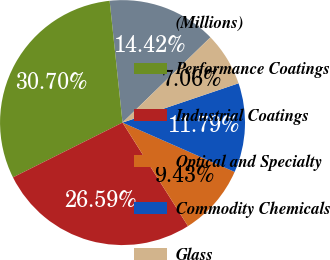<chart> <loc_0><loc_0><loc_500><loc_500><pie_chart><fcel>(Millions)<fcel>Performance Coatings<fcel>Industrial Coatings<fcel>Optical and Specialty<fcel>Commodity Chemicals<fcel>Glass<nl><fcel>14.42%<fcel>30.7%<fcel>26.59%<fcel>9.43%<fcel>11.79%<fcel>7.06%<nl></chart> 